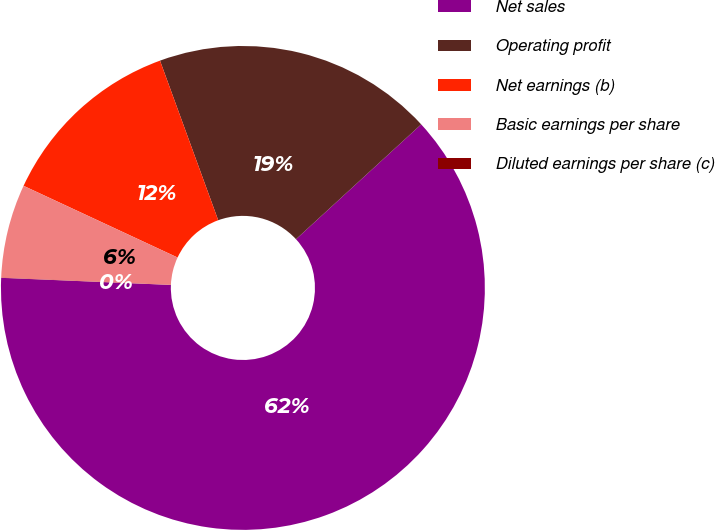<chart> <loc_0><loc_0><loc_500><loc_500><pie_chart><fcel>Net sales<fcel>Operating profit<fcel>Net earnings (b)<fcel>Basic earnings per share<fcel>Diluted earnings per share (c)<nl><fcel>62.48%<fcel>18.75%<fcel>12.5%<fcel>6.26%<fcel>0.01%<nl></chart> 